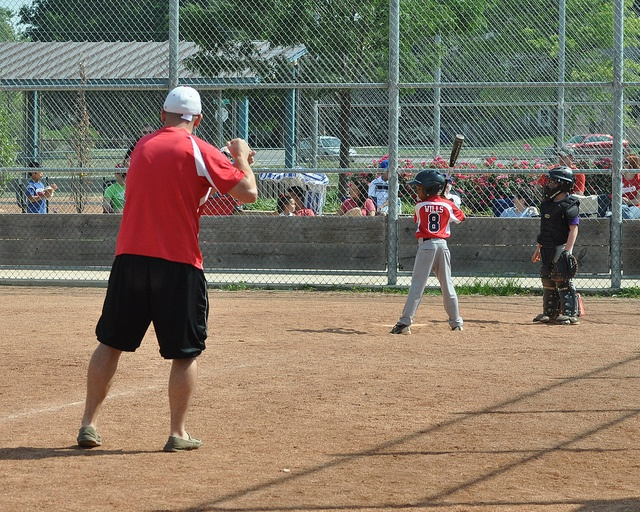Describe the objects in this image and their specific colors. I can see people in lightblue, black, brown, and maroon tones, people in lightblue, black, gray, darkgray, and maroon tones, people in lightblue, gray, black, darkgray, and lightgray tones, people in lightblue, gray, maroon, and darkgray tones, and car in lightblue, gray, and darkgray tones in this image. 